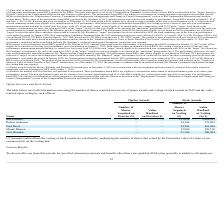According to Xperi Corporation's financial document, What does the table show us? the number of shares acquired on exercise of option awards and vesting of stock awards in 2019 and the value realized upon vesting by such officers. The document states: "The table below sets forth information concerning the number of shares acquired on exercise of option awards and vesting of stock awards in 2019 and t..." Also, How many shares did Jon Kirchner acquire in 2019 through exercise and vesting, respectively? The document shows two values: 0 and 153,090. From the document: "Jon Kirchner — — 153,090 3,428,285 Jon Kirchner — — 153,090 3,428,285..." Also, Which officers are shown in the table? The document contains multiple relevant values: Jon Kirchner, Robert Andersen, Paul Davis, Murali Dharan, Geir Skaaden. From the document: "Murali Dharan — — 15,000 330,120 Robert Andersen — — 24,500 578,806 Jon Kirchner — — 153,090 3,428,285 Paul Davis — — 20,500 482,680 Geir Skaaden — — ..." Also, can you calculate: What is the average number of shares that the officers acquired on vesting? To answer this question, I need to perform calculations using the financial data. The calculation is: (153,090+24,500+20,500+15,000+21,100)/5 , which equals 46838. This is based on the information: "Jon Kirchner — — 153,090 3,428,285 Paul Davis — — 20,500 482,680 Geir Skaaden — — 21,100 500,804 Robert Andersen — — 24,500 578,806 Murali Dharan — — 15,000 330,120..." The key data points involved are: 15,000, 153,090, 20,500. Also, can you calculate: What is the average value per share that Robert Andersen acquired on vesting? Based on the calculation: 578,806/24,500 , the result is 23.62. This is based on the information: "Robert Andersen — — 24,500 578,806 Robert Andersen — — 24,500 578,806..." The key data points involved are: 24,500, 578,806. Additionally, Who acquired the highest amount of shares on vesting? According to the financial document, Jon Kirchner. The relevant text states: "Jon Kirchner — — 153,090 3,428,285..." 